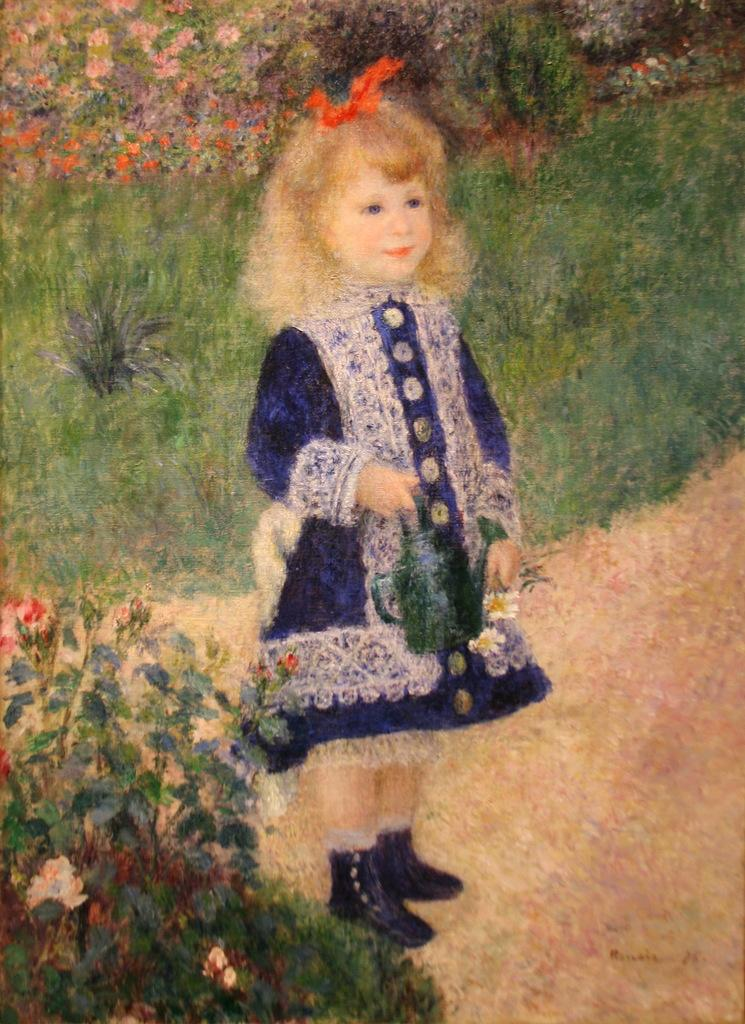Who is the main subject in the image? There is a girl in the image. What is the girl doing in the image? The girl is standing on the ground in the image. What can be seen in the background of the image? There are flower plants and grasses in the background of the image. What is the girl holding in the image? The girl is holding a bottle in the image. What type of industry can be seen in the background of the image? There is no industry present in the image; it features a girl standing on the ground with flower plants and grasses in the background. 